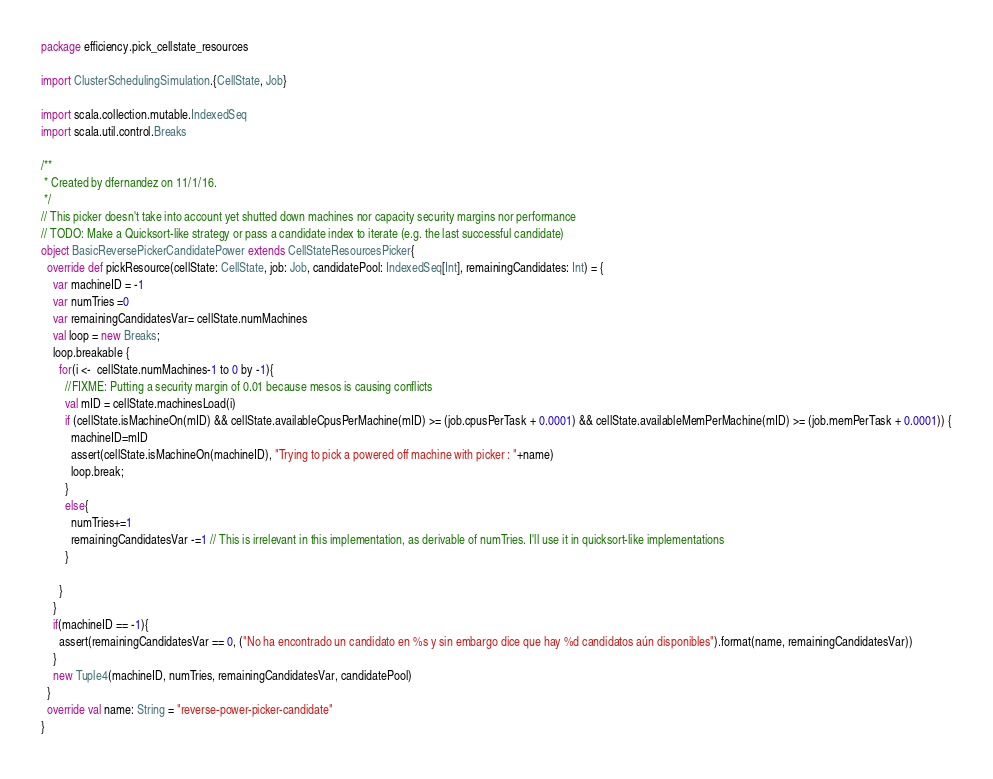<code> <loc_0><loc_0><loc_500><loc_500><_Scala_>package efficiency.pick_cellstate_resources

import ClusterSchedulingSimulation.{CellState, Job}

import scala.collection.mutable.IndexedSeq
import scala.util.control.Breaks

/**
 * Created by dfernandez on 11/1/16.
 */
// This picker doesn't take into account yet shutted down machines nor capacity security margins nor performance
// TODO: Make a Quicksort-like strategy or pass a candidate index to iterate (e.g. the last successful candidate)
object BasicReversePickerCandidatePower extends CellStateResourcesPicker{
  override def pickResource(cellState: CellState, job: Job, candidatePool: IndexedSeq[Int], remainingCandidates: Int) = {
    var machineID = -1
    var numTries =0
    var remainingCandidatesVar= cellState.numMachines
    val loop = new Breaks;
    loop.breakable {
      for(i <-  cellState.numMachines-1 to 0 by -1){
        //FIXME: Putting a security margin of 0.01 because mesos is causing conflicts
        val mID = cellState.machinesLoad(i)
        if (cellState.isMachineOn(mID) && cellState.availableCpusPerMachine(mID) >= (job.cpusPerTask + 0.0001) && cellState.availableMemPerMachine(mID) >= (job.memPerTask + 0.0001)) {
          machineID=mID
          assert(cellState.isMachineOn(machineID), "Trying to pick a powered off machine with picker : "+name)
          loop.break;
        }
        else{
          numTries+=1
          remainingCandidatesVar -=1 // This is irrelevant in this implementation, as derivable of numTries. I'll use it in quicksort-like implementations
        }

      }
    }
    if(machineID == -1){
      assert(remainingCandidatesVar == 0, ("No ha encontrado un candidato en %s y sin embargo dice que hay %d candidatos aún disponibles").format(name, remainingCandidatesVar))
    }
    new Tuple4(machineID, numTries, remainingCandidatesVar, candidatePool)
  }
  override val name: String = "reverse-power-picker-candidate"
}
</code> 